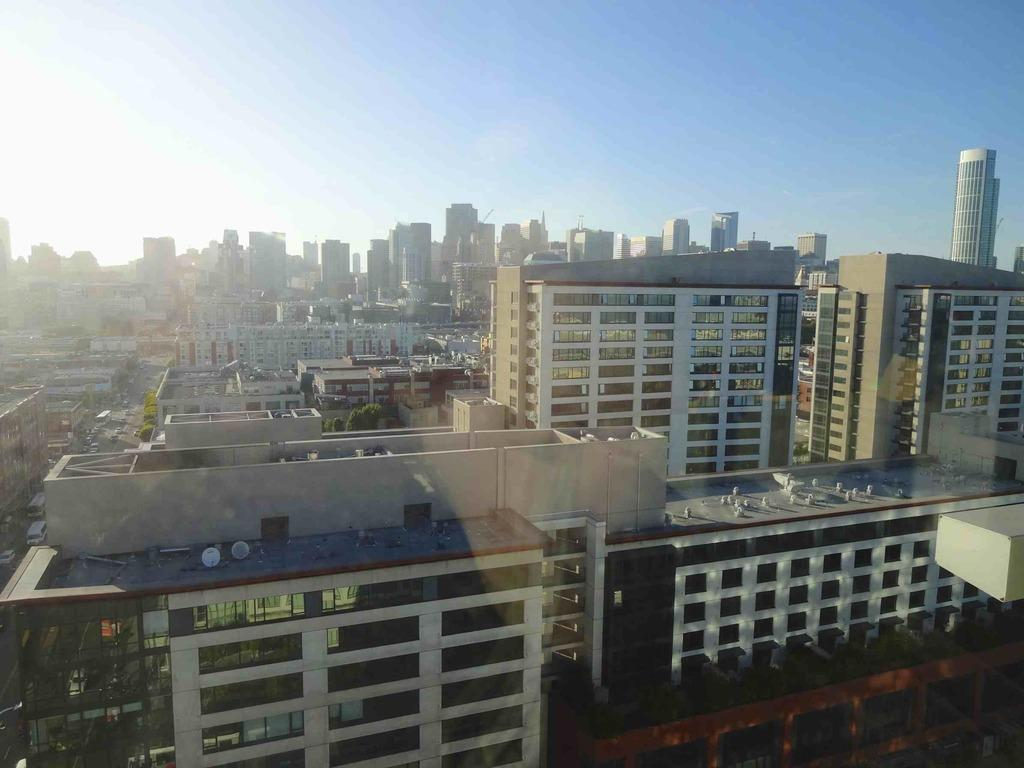What type of structures are present in the image? There are skyscrapers and buildings in the image. What can be seen on top of some of the buildings? Television antennas are visible in the image. What type of vegetation is present in the image? There are trees in the image. What type of transportation is present on the road in the image? Motor vehicles are present on the road in the image. What is visible in the background of the image? The sky is visible in the image, and clouds are present in the sky. What type of mine is visible in the image? There is no mine present in the image. Can you tell me how many lawyers are walking on the sidewalk in the image? There are no lawyers or sidewalks present in the image. What type of butter is being used to grease the television antennas in the image? There is no butter present in the image, and the television antennas are not being greased. 